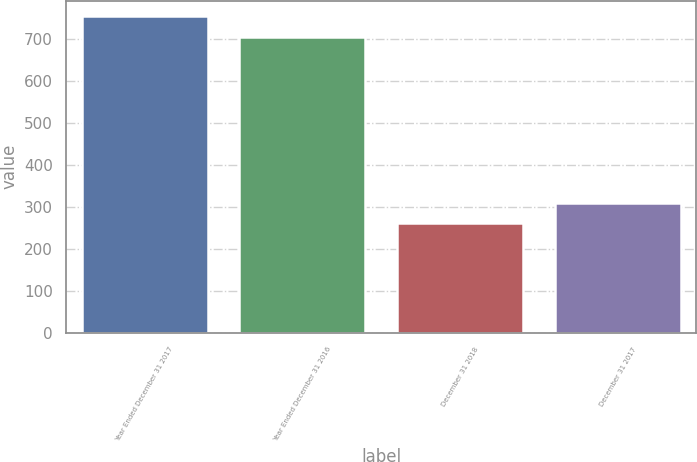Convert chart. <chart><loc_0><loc_0><loc_500><loc_500><bar_chart><fcel>Year Ended December 31 2017<fcel>Year Ended December 31 2016<fcel>December 31 2018<fcel>December 31 2017<nl><fcel>754.68<fcel>706.5<fcel>261<fcel>309.18<nl></chart> 